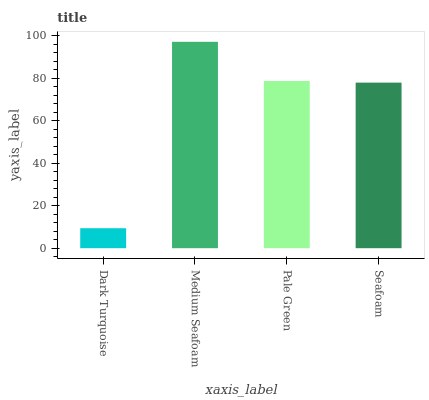Is Pale Green the minimum?
Answer yes or no. No. Is Pale Green the maximum?
Answer yes or no. No. Is Medium Seafoam greater than Pale Green?
Answer yes or no. Yes. Is Pale Green less than Medium Seafoam?
Answer yes or no. Yes. Is Pale Green greater than Medium Seafoam?
Answer yes or no. No. Is Medium Seafoam less than Pale Green?
Answer yes or no. No. Is Pale Green the high median?
Answer yes or no. Yes. Is Seafoam the low median?
Answer yes or no. Yes. Is Dark Turquoise the high median?
Answer yes or no. No. Is Pale Green the low median?
Answer yes or no. No. 